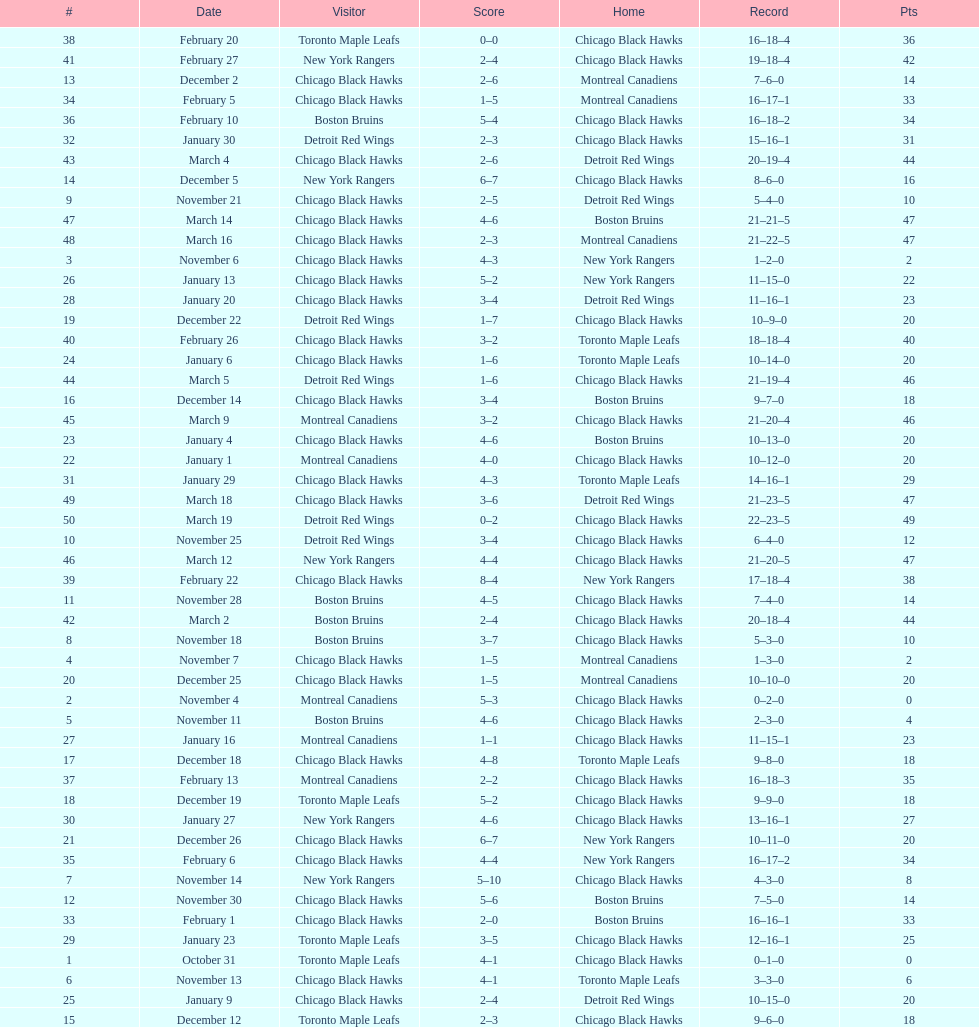What is was the difference in score in the december 19th win? 3. 